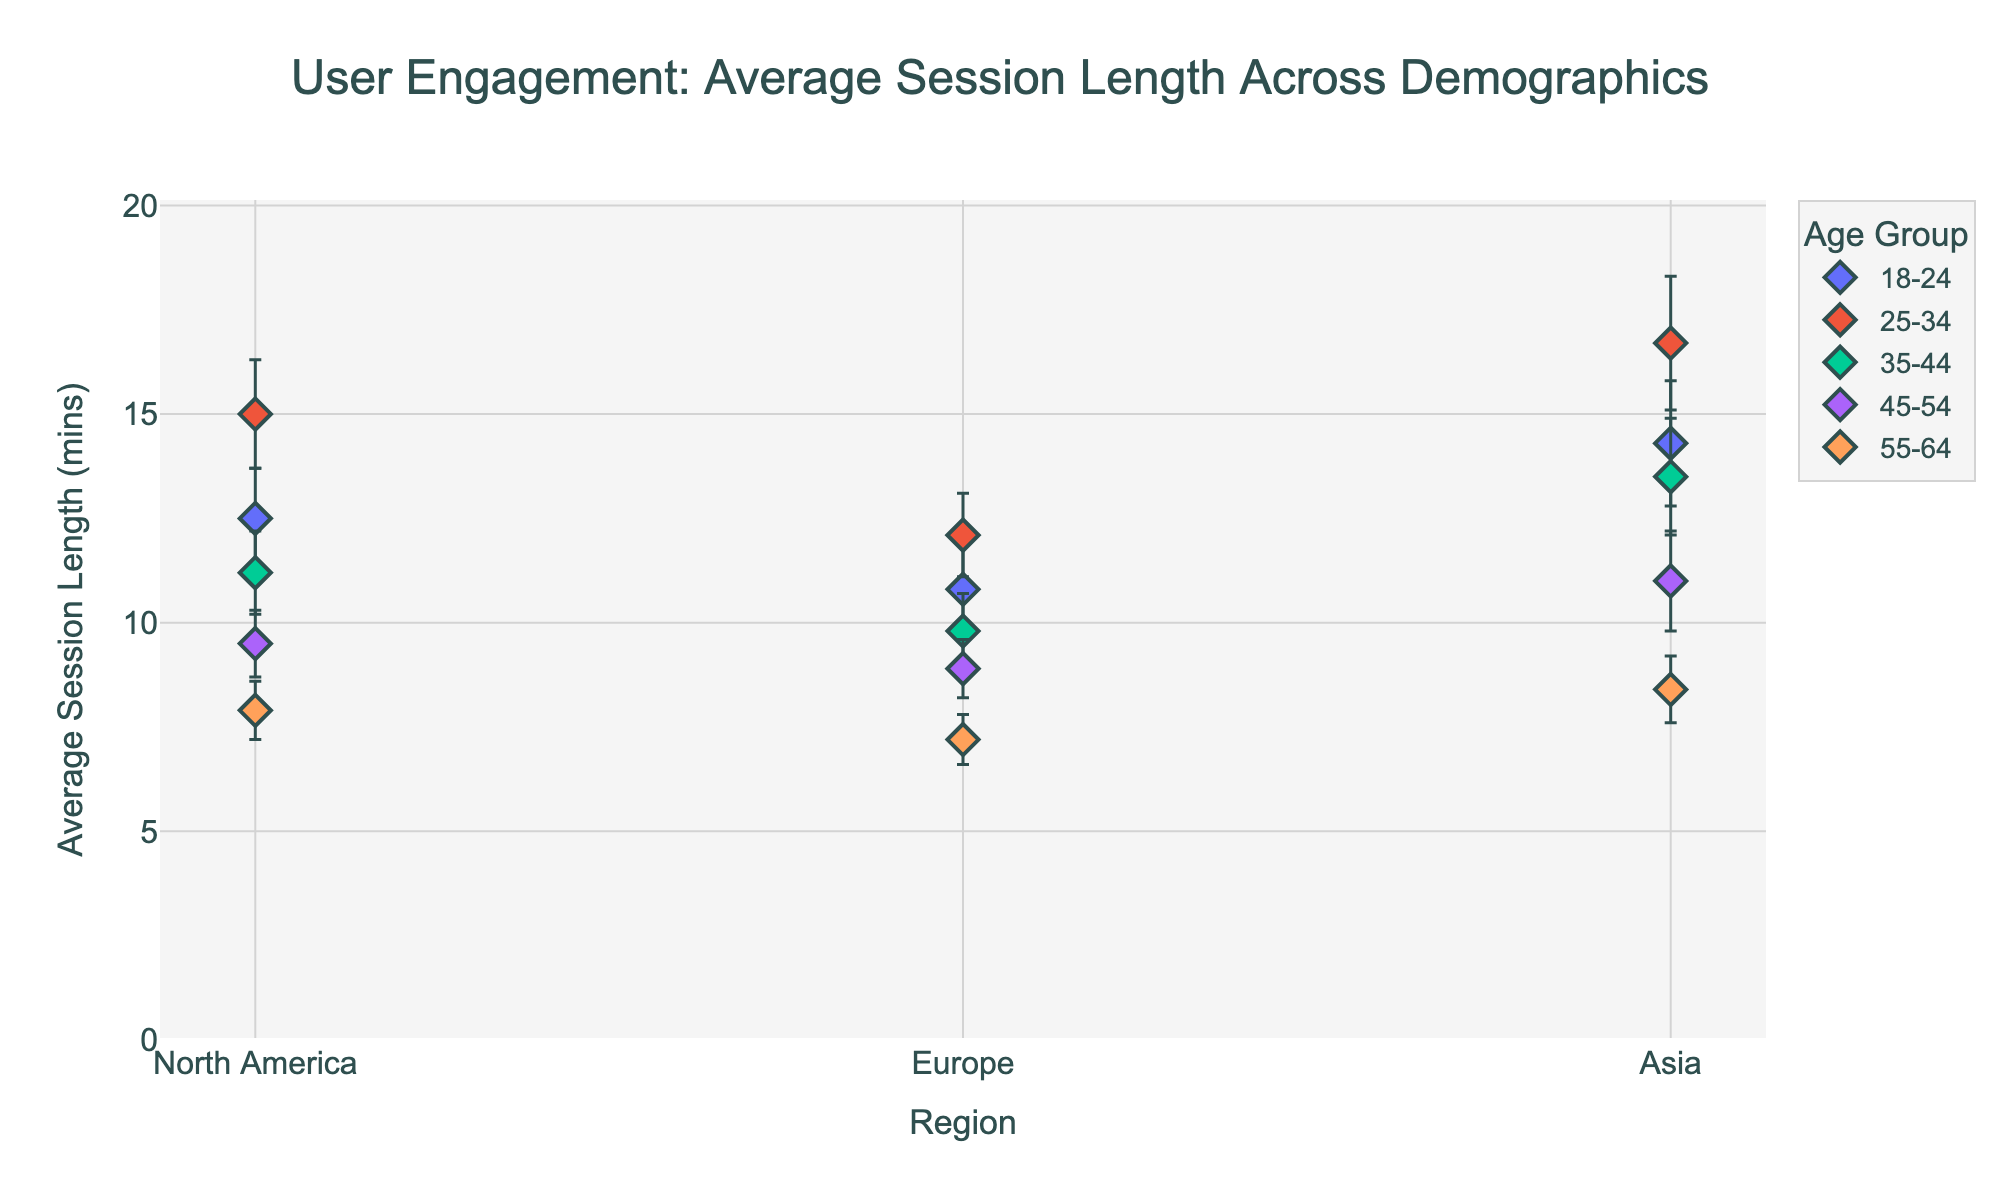What is the title of the plot? The title is visible at the top of the plot and provides a summary of what the plot represents. It reads 'User Engagement: Average Session Length Across Demographics'.
Answer: User Engagement: Average Session Length Across Demographics Which age group has the highest average session length in North America? Locate the North America region along the x-axis, then identify the highest point on the y-axis corresponding to North America. Check which age group this point belongs to. It is the 25-34 age group with an average session length of 15.0 minutes.
Answer: 25-34 What region has the lowest average session length for the age group 55-64? Focus on the points representing the 55-64 age group, then see which point has the lowest y-value (session length). This occurs in Europe with an average session length of 7.2 minutes.
Answer: Europe What is the range of average session lengths for the age group 18-24 across all regions? Identify the maximum and minimum session lengths for the 18-24 age group. The maximum is 14.3 (Asia) and the minimum is 10.8 (Europe). The range is calculated as 14.3 - 10.8 = 3.5 minutes.
Answer: 3.5 minutes How do the error bars for average session length in Asia compare to those in North America for the 25-34 age group? Look at the error bars (vertical lines) for the 25-34 age group in the regions of Asia and North America. In Asia, the error bar length is 1.6 minutes, while in North America it is 1.3 minutes. The error bar for Asia is slightly larger.
Answer: Asia has larger error bars Which region has the highest average session length for the 45-54 age group? Evaluate the average session length for the 45-54 age group across all regions. In Asia, it reaches 11.0 minutes, which is higher than both North America (9.5 minutes) and Europe (8.9 minutes).
Answer: Asia Are there any age groups where the average session length is the same across two regions? Compare the session lengths for each age group across different regions. This direct comparison reveals no identical average session lengths across any two regions for any age group.
Answer: No Which age group has the smallest variation in session length across all regions? Calculate the difference between the highest and lowest session lengths for each age group across the regions. The smallest difference corresponds to the 55-64 age group, where the variation is 8.4 - 7.2 = 1.2 minutes.
Answer: 55-64 What is the overall trend in session length as age increases within each region? Observe the overall trend from the youngest (18-24) to oldest (55-64) age groups in each region. Generally, session length decreases as age increases. For example, in North America, it decreases from 12.5 (18-24) to 7.9 (55-64).
Answer: Decreasing trend What is the combined average session length for the 25-34 age group across all regions? Average the session lengths for the 25-34 age group across the regions: (15.0 + 12.1 + 16.7) / 3. Compute the sum 15.0 + 12.1 + 16.7 = 43.8, then divide by 3 to get 43.8 / 3 = 14.6 minutes.
Answer: 14.6 minutes 